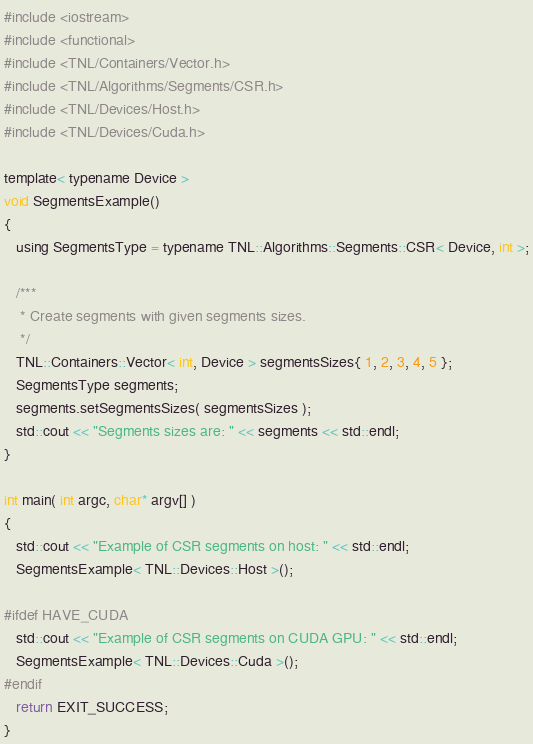Convert code to text. <code><loc_0><loc_0><loc_500><loc_500><_Cuda_>#include <iostream>
#include <functional>
#include <TNL/Containers/Vector.h>
#include <TNL/Algorithms/Segments/CSR.h>
#include <TNL/Devices/Host.h>
#include <TNL/Devices/Cuda.h>

template< typename Device >
void SegmentsExample()
{
   using SegmentsType = typename TNL::Algorithms::Segments::CSR< Device, int >;

   /***
    * Create segments with given segments sizes.
    */
   TNL::Containers::Vector< int, Device > segmentsSizes{ 1, 2, 3, 4, 5 };
   SegmentsType segments;
   segments.setSegmentsSizes( segmentsSizes );
   std::cout << "Segments sizes are: " << segments << std::endl;
}

int main( int argc, char* argv[] )
{
   std::cout << "Example of CSR segments on host: " << std::endl;
   SegmentsExample< TNL::Devices::Host >();

#ifdef HAVE_CUDA
   std::cout << "Example of CSR segments on CUDA GPU: " << std::endl;
   SegmentsExample< TNL::Devices::Cuda >();
#endif
   return EXIT_SUCCESS;
}
</code> 